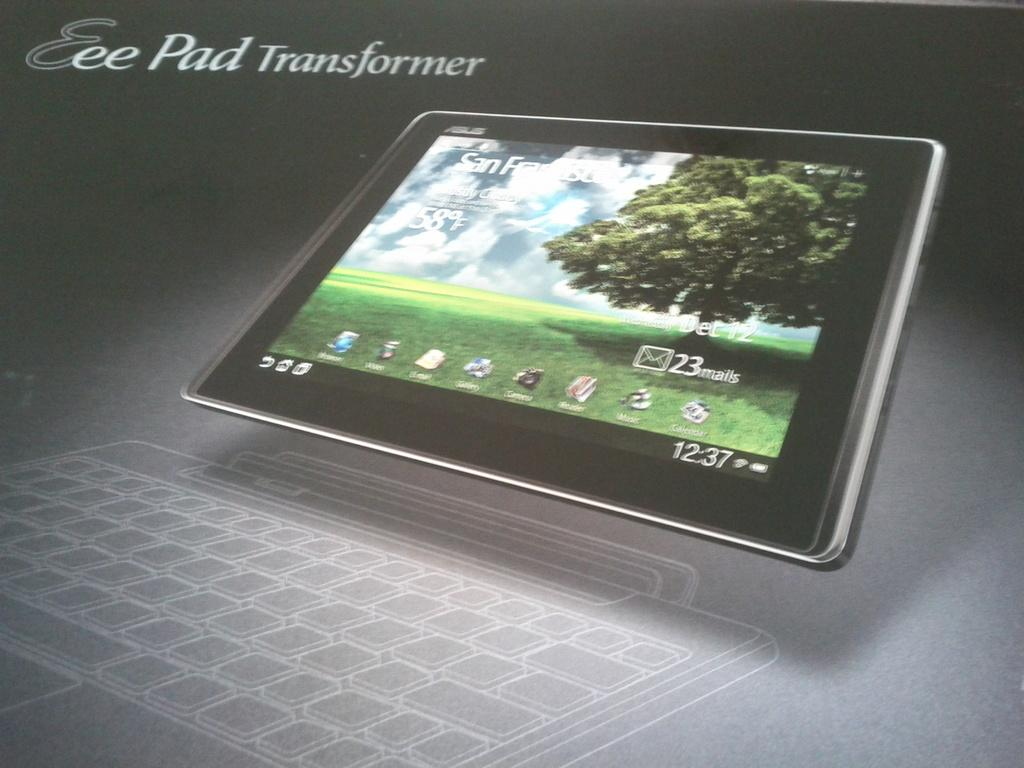What type of media is the image? The image is an animation. What object is located in the center of the image? There is a tablet in the center of the image. What feature is present at the bottom of the image? There is a keypad at the bottom of the image. What can be seen written or displayed in the image? Text is visible in the image. What type of goat can be seen wearing a shirt and drinking from a glass in the image? There is no goat, shirt, or glass present in the image; it is an animation featuring a tablet and keypad with text. 